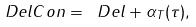Convert formula to latex. <formula><loc_0><loc_0><loc_500><loc_500>\ D e l C o n = \ D e l + \alpha _ { T } ( \tau ) ,</formula> 